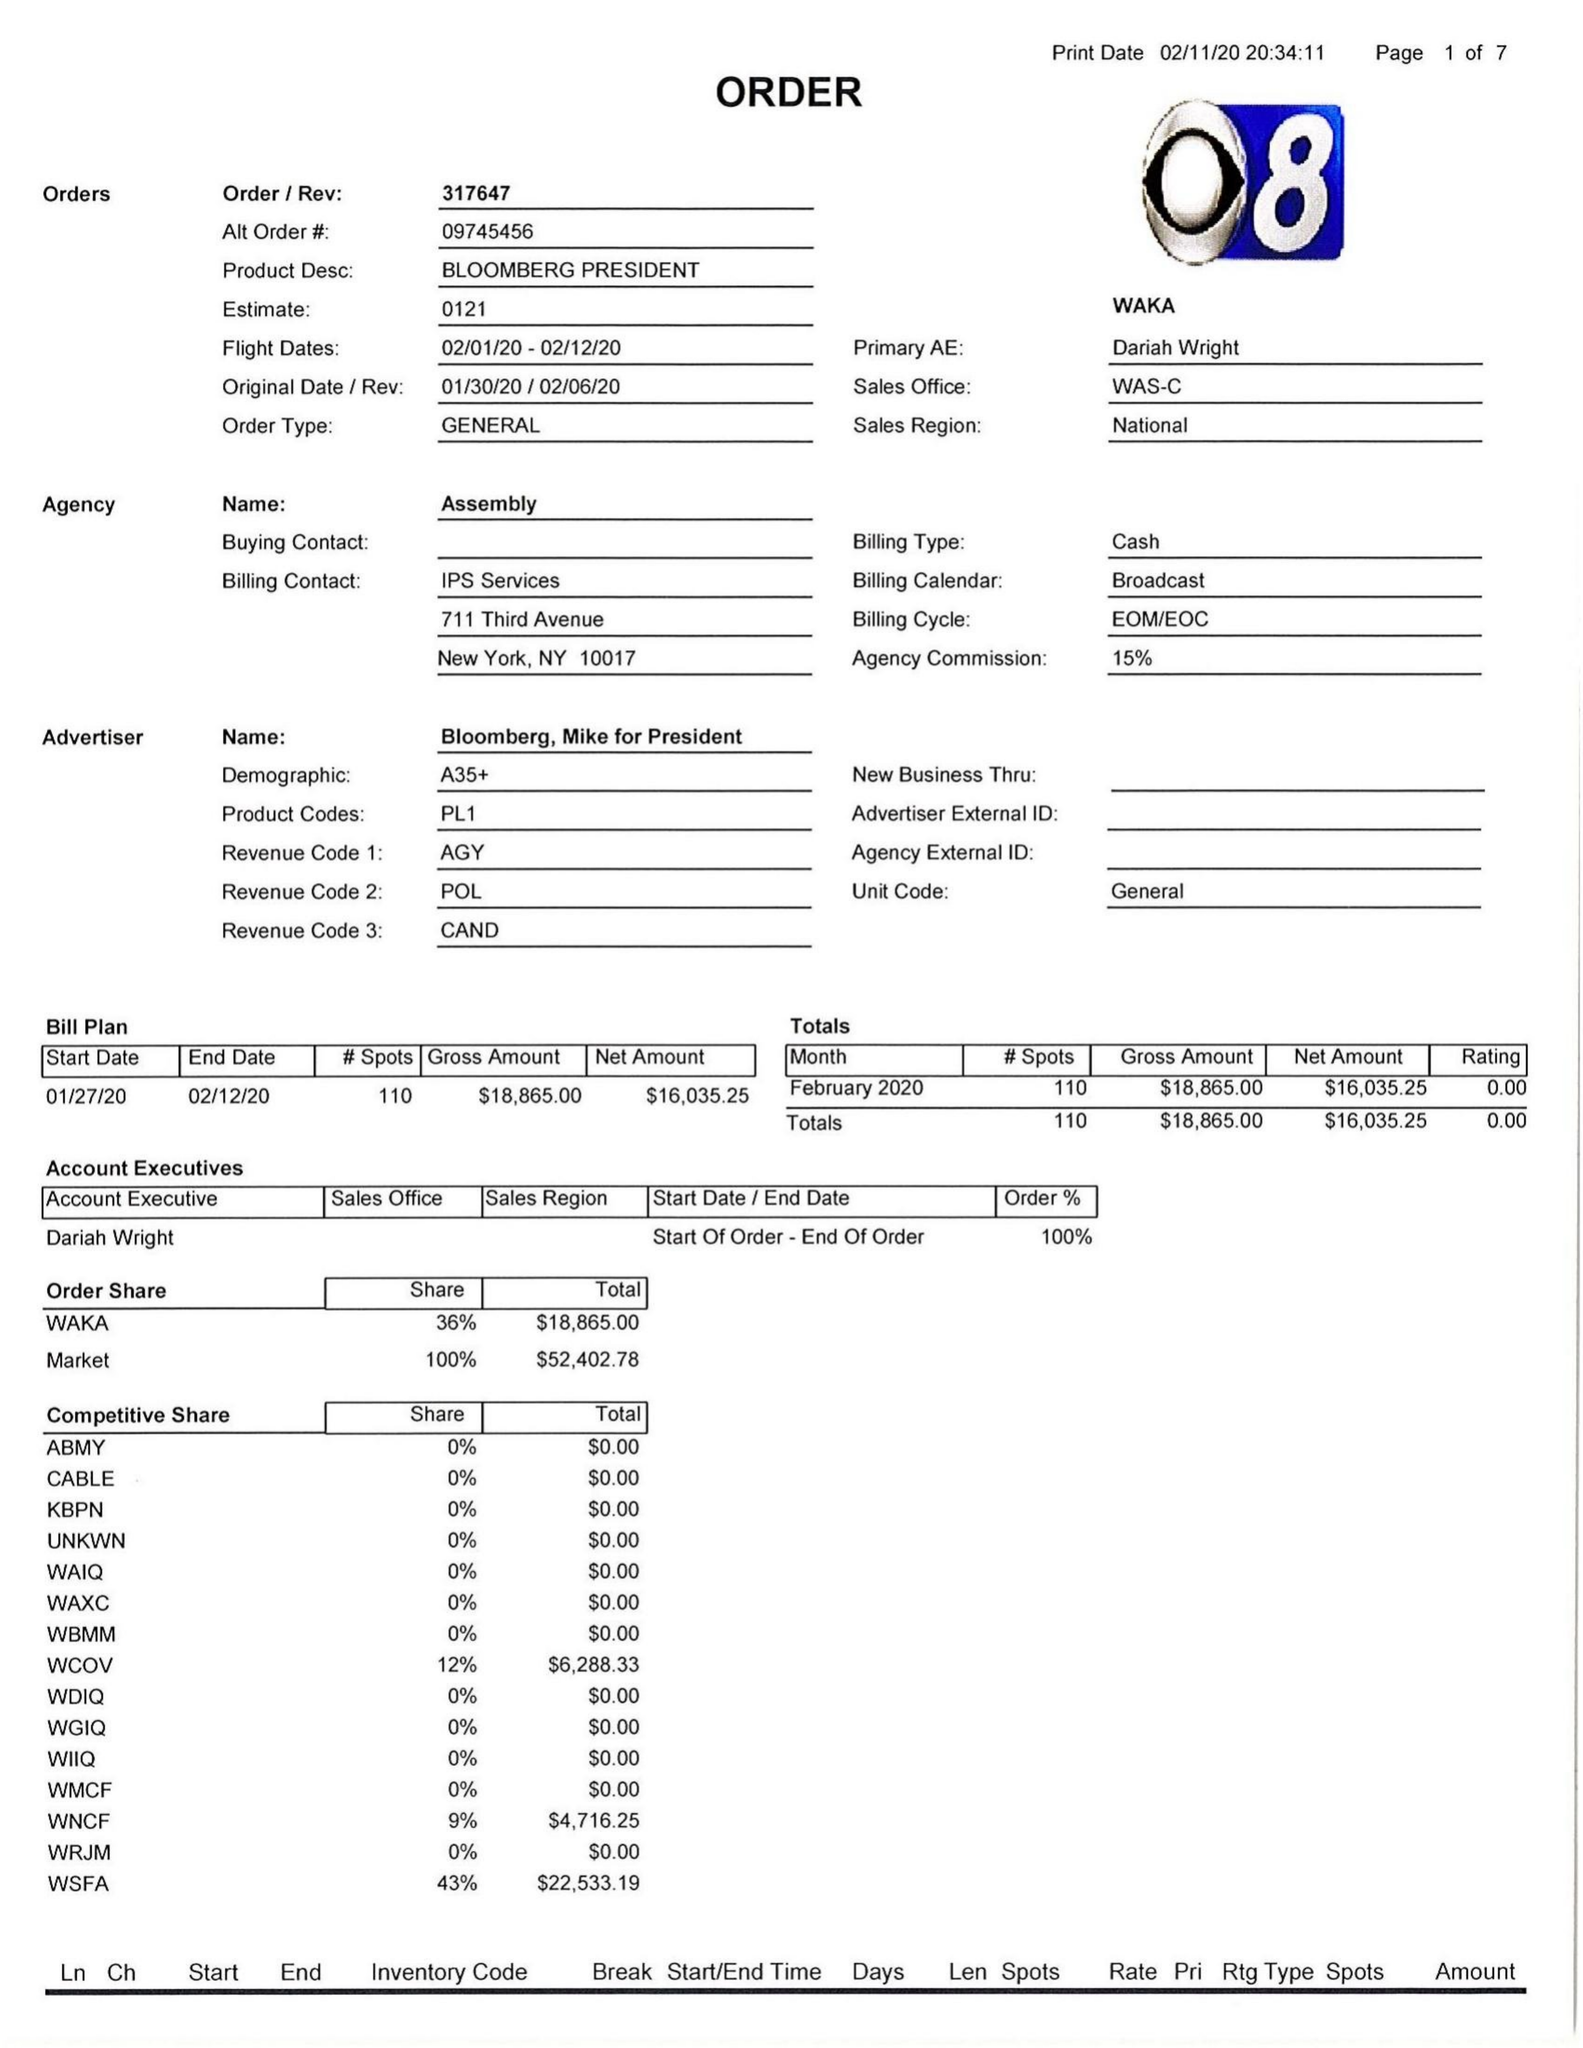What is the value for the flight_to?
Answer the question using a single word or phrase. 02/12/20 